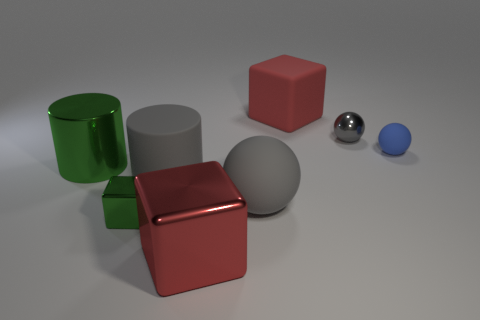Subtract all large gray spheres. How many spheres are left? 2 Subtract all purple cylinders. How many gray balls are left? 2 Add 2 big cyan rubber blocks. How many objects exist? 10 Subtract all cylinders. How many objects are left? 6 Subtract all purple cubes. Subtract all yellow cylinders. How many cubes are left? 3 Add 2 tiny cyan blocks. How many tiny cyan blocks exist? 2 Subtract 0 brown cubes. How many objects are left? 8 Subtract all tiny blue rubber objects. Subtract all large gray spheres. How many objects are left? 6 Add 2 large rubber blocks. How many large rubber blocks are left? 3 